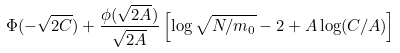<formula> <loc_0><loc_0><loc_500><loc_500>\Phi ( - \sqrt { 2 C } ) + \frac { \phi ( \sqrt { 2 A } ) } { \sqrt { 2 A } } \left [ \log \sqrt { N / m _ { 0 } } - 2 + A \log ( C / A ) \right ]</formula> 